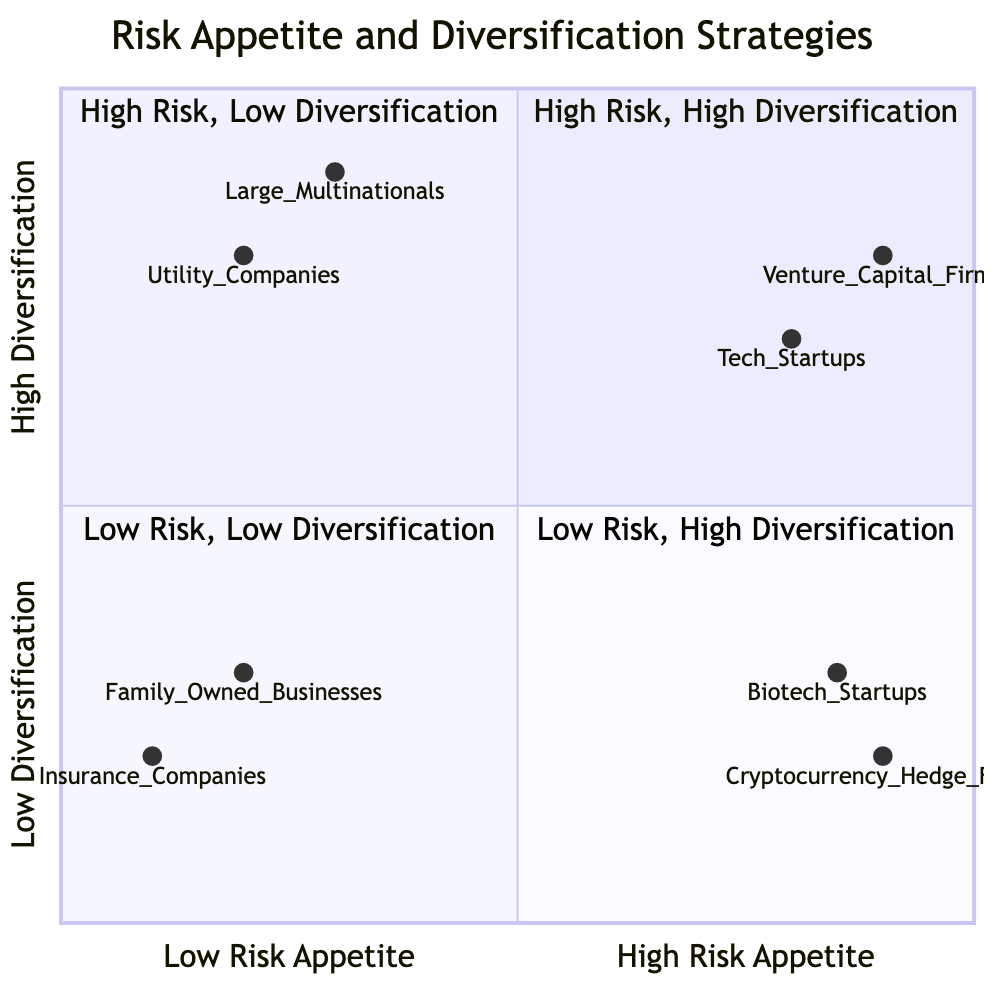What are the examples in the "High Risk Appetite, High Diversification" quadrant? The "High Risk Appetite, High Diversification" quadrant contains "Tech Startups" and "Venture Capital Firms" as examples.
Answer: Tech Startups, Venture Capital Firms How many examples are listed in the "Low Risk Appetite, Low Diversification" quadrant? The "Low Risk Appetite, Low Diversification" quadrant contains two examples: "Family-Owned Businesses" and "Insurance Companies." Therefore, there are a total of two examples in this quadrant.
Answer: 2 What are the strategies for "Large Multinational Corporations"? The strategies listed for "Large Multinational Corporations" in the "Low Risk Appetite, High Diversification" quadrant are "Diversifying investments across various sectors to spread risk" and "Focusing on stable and predictable market segments."
Answer: Diversifying investments across various sectors to spread risk, Focusing on stable and predictable market segments Which example is positioned at the highest point on the y-axis? "Venture Capital Firms" is positioned at the highest point on the y-axis within the "High Risk Appetite, High Diversification" quadrant at a value of 0.8, indicating a strong level of diversification.
Answer: Venture Capital Firms Are any examples in the "Low Risk Appetite, Low Diversification" quadrant focused on low-risk markets? Yes, both "Family-Owned Businesses" and "Insurance Companies," which are the examples in the "Low Risk Appetite, Low Diversification" quadrant, prioritize established, low-risk markets.
Answer: Yes What is the risk appetite score of "Utility Companies"? "Utility Companies" have a risk appetite score of 0.2 on the x-axis, indicating a low risk appetite.
Answer: 0.2 Which quadrant contains examples that focus on cutting-edge research? The "High Risk Appetite, Low Diversification" quadrant contains examples such as "Cryptocurrency Hedge Funds" and "Biotech Startups," which focus on cutting-edge research for a competitive edge.
Answer: High Risk Appetite, Low Diversification How many quadrants are represented in the diagram? The diagram features four quadrants: High Risk Appetite, High Diversification; High Risk Appetite, Low Diversification; Low Risk Appetite, High Diversification; and Low Risk Appetite, Low Diversification. Therefore, there are four quadrants in total.
Answer: 4 